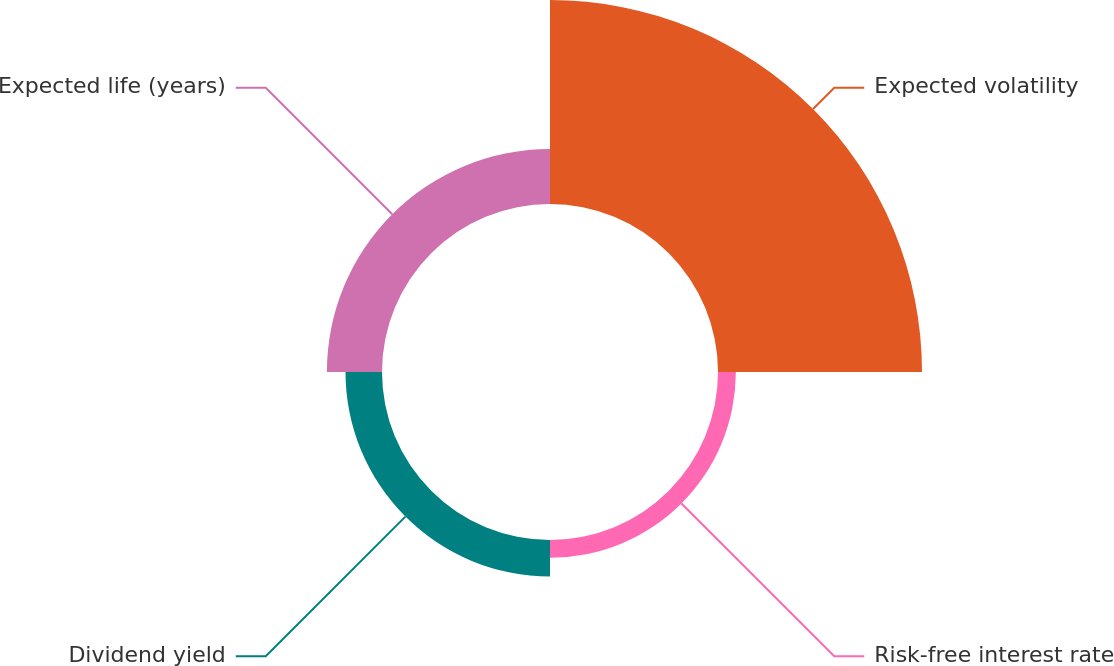Convert chart. <chart><loc_0><loc_0><loc_500><loc_500><pie_chart><fcel>Expected volatility<fcel>Risk-free interest rate<fcel>Dividend yield<fcel>Expected life (years)<nl><fcel>65.09%<fcel>5.7%<fcel>11.64%<fcel>17.58%<nl></chart> 